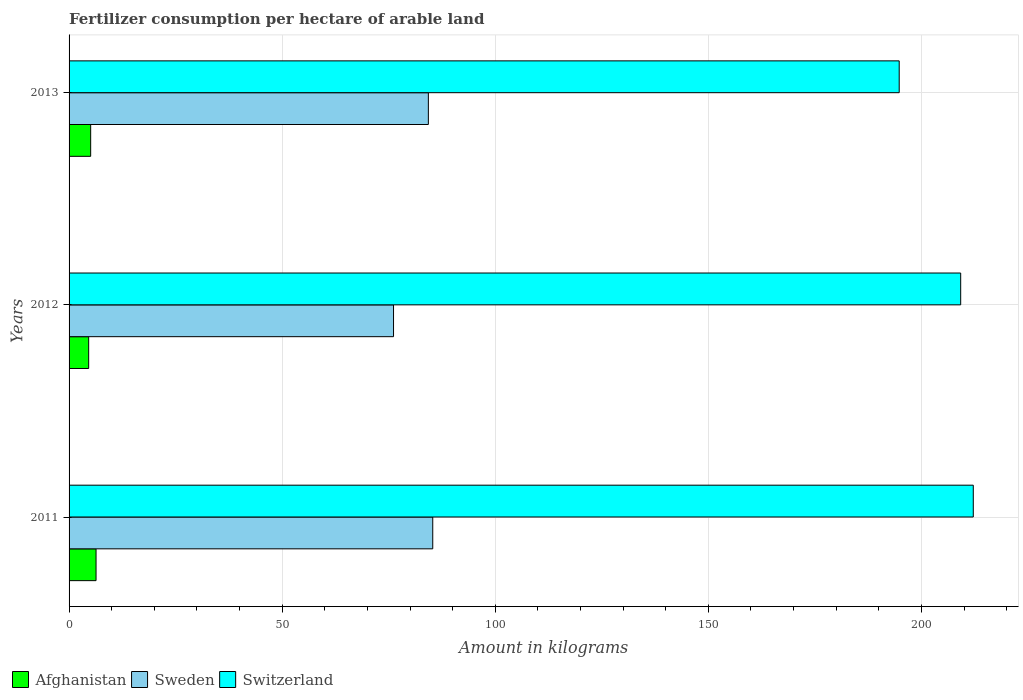Are the number of bars per tick equal to the number of legend labels?
Your answer should be very brief. Yes. How many bars are there on the 3rd tick from the top?
Offer a very short reply. 3. What is the label of the 3rd group of bars from the top?
Ensure brevity in your answer.  2011. What is the amount of fertilizer consumption in Afghanistan in 2012?
Your answer should be very brief. 4.6. Across all years, what is the maximum amount of fertilizer consumption in Switzerland?
Provide a short and direct response. 212.16. Across all years, what is the minimum amount of fertilizer consumption in Afghanistan?
Give a very brief answer. 4.6. What is the total amount of fertilizer consumption in Afghanistan in the graph?
Provide a succinct answer. 16. What is the difference between the amount of fertilizer consumption in Afghanistan in 2011 and that in 2012?
Your response must be concise. 1.73. What is the difference between the amount of fertilizer consumption in Switzerland in 2011 and the amount of fertilizer consumption in Afghanistan in 2012?
Make the answer very short. 207.56. What is the average amount of fertilizer consumption in Sweden per year?
Give a very brief answer. 81.92. In the year 2011, what is the difference between the amount of fertilizer consumption in Switzerland and amount of fertilizer consumption in Sweden?
Provide a short and direct response. 126.83. What is the ratio of the amount of fertilizer consumption in Sweden in 2012 to that in 2013?
Your response must be concise. 0.9. Is the amount of fertilizer consumption in Afghanistan in 2011 less than that in 2013?
Provide a short and direct response. No. What is the difference between the highest and the second highest amount of fertilizer consumption in Switzerland?
Offer a terse response. 2.96. What is the difference between the highest and the lowest amount of fertilizer consumption in Sweden?
Offer a very short reply. 9.2. Is the sum of the amount of fertilizer consumption in Sweden in 2012 and 2013 greater than the maximum amount of fertilizer consumption in Switzerland across all years?
Offer a very short reply. No. Is it the case that in every year, the sum of the amount of fertilizer consumption in Afghanistan and amount of fertilizer consumption in Sweden is greater than the amount of fertilizer consumption in Switzerland?
Your answer should be compact. No. Are the values on the major ticks of X-axis written in scientific E-notation?
Ensure brevity in your answer.  No. Does the graph contain any zero values?
Ensure brevity in your answer.  No. Does the graph contain grids?
Your response must be concise. Yes. Where does the legend appear in the graph?
Your response must be concise. Bottom left. How many legend labels are there?
Provide a succinct answer. 3. What is the title of the graph?
Your response must be concise. Fertilizer consumption per hectare of arable land. What is the label or title of the X-axis?
Provide a short and direct response. Amount in kilograms. What is the label or title of the Y-axis?
Offer a very short reply. Years. What is the Amount in kilograms of Afghanistan in 2011?
Keep it short and to the point. 6.33. What is the Amount in kilograms of Sweden in 2011?
Offer a very short reply. 85.33. What is the Amount in kilograms of Switzerland in 2011?
Provide a short and direct response. 212.16. What is the Amount in kilograms of Afghanistan in 2012?
Ensure brevity in your answer.  4.6. What is the Amount in kilograms in Sweden in 2012?
Provide a succinct answer. 76.13. What is the Amount in kilograms of Switzerland in 2012?
Make the answer very short. 209.21. What is the Amount in kilograms in Afghanistan in 2013?
Make the answer very short. 5.07. What is the Amount in kilograms in Sweden in 2013?
Your response must be concise. 84.3. What is the Amount in kilograms of Switzerland in 2013?
Give a very brief answer. 194.78. Across all years, what is the maximum Amount in kilograms in Afghanistan?
Your answer should be compact. 6.33. Across all years, what is the maximum Amount in kilograms in Sweden?
Your response must be concise. 85.33. Across all years, what is the maximum Amount in kilograms in Switzerland?
Give a very brief answer. 212.16. Across all years, what is the minimum Amount in kilograms of Afghanistan?
Make the answer very short. 4.6. Across all years, what is the minimum Amount in kilograms in Sweden?
Your answer should be very brief. 76.13. Across all years, what is the minimum Amount in kilograms in Switzerland?
Provide a succinct answer. 194.78. What is the total Amount in kilograms in Afghanistan in the graph?
Make the answer very short. 16. What is the total Amount in kilograms of Sweden in the graph?
Give a very brief answer. 245.77. What is the total Amount in kilograms in Switzerland in the graph?
Keep it short and to the point. 616.15. What is the difference between the Amount in kilograms in Afghanistan in 2011 and that in 2012?
Give a very brief answer. 1.73. What is the difference between the Amount in kilograms of Sweden in 2011 and that in 2012?
Your answer should be compact. 9.2. What is the difference between the Amount in kilograms in Switzerland in 2011 and that in 2012?
Keep it short and to the point. 2.96. What is the difference between the Amount in kilograms in Afghanistan in 2011 and that in 2013?
Your response must be concise. 1.26. What is the difference between the Amount in kilograms of Sweden in 2011 and that in 2013?
Your response must be concise. 1.03. What is the difference between the Amount in kilograms of Switzerland in 2011 and that in 2013?
Your answer should be compact. 17.38. What is the difference between the Amount in kilograms in Afghanistan in 2012 and that in 2013?
Ensure brevity in your answer.  -0.47. What is the difference between the Amount in kilograms in Sweden in 2012 and that in 2013?
Make the answer very short. -8.17. What is the difference between the Amount in kilograms in Switzerland in 2012 and that in 2013?
Offer a very short reply. 14.42. What is the difference between the Amount in kilograms of Afghanistan in 2011 and the Amount in kilograms of Sweden in 2012?
Your answer should be compact. -69.8. What is the difference between the Amount in kilograms of Afghanistan in 2011 and the Amount in kilograms of Switzerland in 2012?
Ensure brevity in your answer.  -202.88. What is the difference between the Amount in kilograms in Sweden in 2011 and the Amount in kilograms in Switzerland in 2012?
Keep it short and to the point. -123.87. What is the difference between the Amount in kilograms in Afghanistan in 2011 and the Amount in kilograms in Sweden in 2013?
Make the answer very short. -77.97. What is the difference between the Amount in kilograms in Afghanistan in 2011 and the Amount in kilograms in Switzerland in 2013?
Your response must be concise. -188.45. What is the difference between the Amount in kilograms in Sweden in 2011 and the Amount in kilograms in Switzerland in 2013?
Make the answer very short. -109.45. What is the difference between the Amount in kilograms of Afghanistan in 2012 and the Amount in kilograms of Sweden in 2013?
Offer a very short reply. -79.7. What is the difference between the Amount in kilograms in Afghanistan in 2012 and the Amount in kilograms in Switzerland in 2013?
Your answer should be very brief. -190.18. What is the difference between the Amount in kilograms of Sweden in 2012 and the Amount in kilograms of Switzerland in 2013?
Your response must be concise. -118.65. What is the average Amount in kilograms of Afghanistan per year?
Offer a terse response. 5.33. What is the average Amount in kilograms in Sweden per year?
Make the answer very short. 81.92. What is the average Amount in kilograms in Switzerland per year?
Provide a succinct answer. 205.38. In the year 2011, what is the difference between the Amount in kilograms in Afghanistan and Amount in kilograms in Sweden?
Offer a very short reply. -79. In the year 2011, what is the difference between the Amount in kilograms in Afghanistan and Amount in kilograms in Switzerland?
Ensure brevity in your answer.  -205.83. In the year 2011, what is the difference between the Amount in kilograms in Sweden and Amount in kilograms in Switzerland?
Your answer should be very brief. -126.83. In the year 2012, what is the difference between the Amount in kilograms of Afghanistan and Amount in kilograms of Sweden?
Your response must be concise. -71.53. In the year 2012, what is the difference between the Amount in kilograms of Afghanistan and Amount in kilograms of Switzerland?
Make the answer very short. -204.61. In the year 2012, what is the difference between the Amount in kilograms in Sweden and Amount in kilograms in Switzerland?
Keep it short and to the point. -133.08. In the year 2013, what is the difference between the Amount in kilograms of Afghanistan and Amount in kilograms of Sweden?
Provide a succinct answer. -79.23. In the year 2013, what is the difference between the Amount in kilograms in Afghanistan and Amount in kilograms in Switzerland?
Give a very brief answer. -189.71. In the year 2013, what is the difference between the Amount in kilograms of Sweden and Amount in kilograms of Switzerland?
Provide a succinct answer. -110.48. What is the ratio of the Amount in kilograms in Afghanistan in 2011 to that in 2012?
Offer a terse response. 1.38. What is the ratio of the Amount in kilograms in Sweden in 2011 to that in 2012?
Provide a succinct answer. 1.12. What is the ratio of the Amount in kilograms of Switzerland in 2011 to that in 2012?
Make the answer very short. 1.01. What is the ratio of the Amount in kilograms of Afghanistan in 2011 to that in 2013?
Offer a terse response. 1.25. What is the ratio of the Amount in kilograms in Sweden in 2011 to that in 2013?
Ensure brevity in your answer.  1.01. What is the ratio of the Amount in kilograms in Switzerland in 2011 to that in 2013?
Offer a terse response. 1.09. What is the ratio of the Amount in kilograms in Afghanistan in 2012 to that in 2013?
Give a very brief answer. 0.91. What is the ratio of the Amount in kilograms in Sweden in 2012 to that in 2013?
Your answer should be compact. 0.9. What is the ratio of the Amount in kilograms of Switzerland in 2012 to that in 2013?
Offer a very short reply. 1.07. What is the difference between the highest and the second highest Amount in kilograms of Afghanistan?
Your answer should be very brief. 1.26. What is the difference between the highest and the second highest Amount in kilograms in Sweden?
Your answer should be very brief. 1.03. What is the difference between the highest and the second highest Amount in kilograms of Switzerland?
Make the answer very short. 2.96. What is the difference between the highest and the lowest Amount in kilograms of Afghanistan?
Make the answer very short. 1.73. What is the difference between the highest and the lowest Amount in kilograms in Sweden?
Your response must be concise. 9.2. What is the difference between the highest and the lowest Amount in kilograms of Switzerland?
Keep it short and to the point. 17.38. 